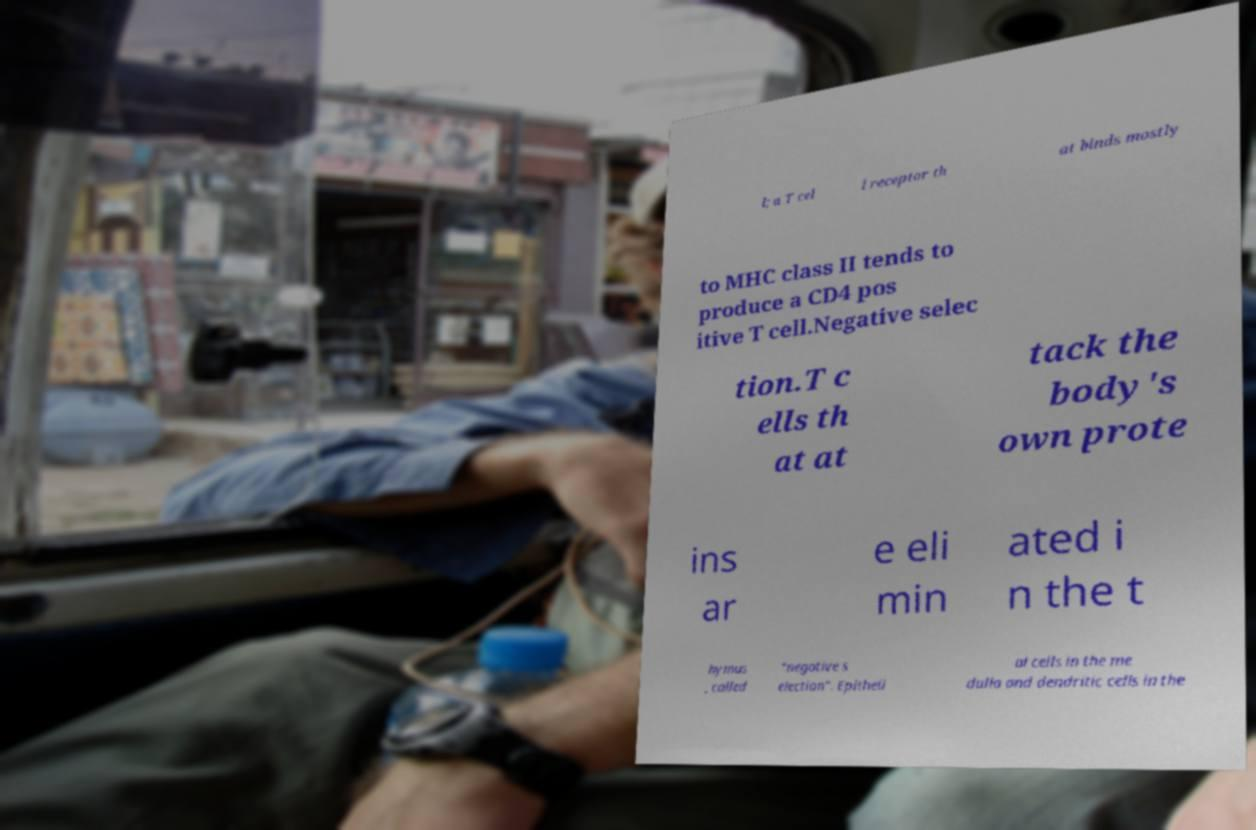Can you read and provide the text displayed in the image?This photo seems to have some interesting text. Can you extract and type it out for me? l; a T cel l receptor th at binds mostly to MHC class II tends to produce a CD4 pos itive T cell.Negative selec tion.T c ells th at at tack the body's own prote ins ar e eli min ated i n the t hymus , called "negative s election". Epitheli al cells in the me dulla and dendritic cells in the 